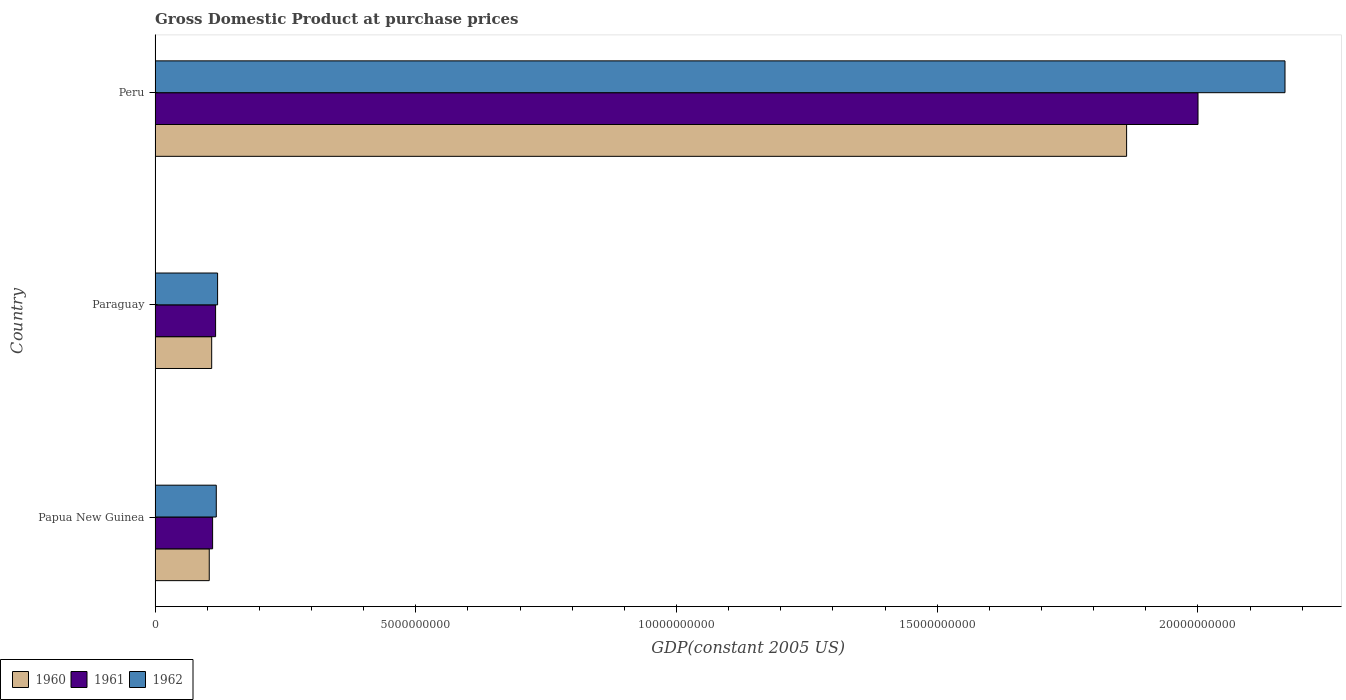How many different coloured bars are there?
Keep it short and to the point. 3. Are the number of bars per tick equal to the number of legend labels?
Offer a very short reply. Yes. What is the label of the 2nd group of bars from the top?
Your answer should be very brief. Paraguay. In how many cases, is the number of bars for a given country not equal to the number of legend labels?
Provide a short and direct response. 0. What is the GDP at purchase prices in 1961 in Paraguay?
Ensure brevity in your answer.  1.16e+09. Across all countries, what is the maximum GDP at purchase prices in 1961?
Your answer should be very brief. 2.00e+1. Across all countries, what is the minimum GDP at purchase prices in 1960?
Your response must be concise. 1.04e+09. In which country was the GDP at purchase prices in 1961 minimum?
Offer a terse response. Papua New Guinea. What is the total GDP at purchase prices in 1961 in the graph?
Keep it short and to the point. 2.23e+1. What is the difference between the GDP at purchase prices in 1961 in Papua New Guinea and that in Peru?
Offer a terse response. -1.89e+1. What is the difference between the GDP at purchase prices in 1962 in Peru and the GDP at purchase prices in 1960 in Papua New Guinea?
Provide a succinct answer. 2.06e+1. What is the average GDP at purchase prices in 1961 per country?
Provide a succinct answer. 7.42e+09. What is the difference between the GDP at purchase prices in 1961 and GDP at purchase prices in 1962 in Paraguay?
Your answer should be compact. -3.83e+07. What is the ratio of the GDP at purchase prices in 1961 in Papua New Guinea to that in Peru?
Keep it short and to the point. 0.06. What is the difference between the highest and the second highest GDP at purchase prices in 1961?
Make the answer very short. 1.88e+1. What is the difference between the highest and the lowest GDP at purchase prices in 1961?
Offer a terse response. 1.89e+1. Is the sum of the GDP at purchase prices in 1960 in Papua New Guinea and Peru greater than the maximum GDP at purchase prices in 1961 across all countries?
Provide a succinct answer. No. What does the 3rd bar from the bottom in Papua New Guinea represents?
Make the answer very short. 1962. How many countries are there in the graph?
Your answer should be very brief. 3. What is the difference between two consecutive major ticks on the X-axis?
Keep it short and to the point. 5.00e+09. Does the graph contain grids?
Provide a succinct answer. No. How many legend labels are there?
Your response must be concise. 3. How are the legend labels stacked?
Provide a short and direct response. Horizontal. What is the title of the graph?
Offer a terse response. Gross Domestic Product at purchase prices. What is the label or title of the X-axis?
Make the answer very short. GDP(constant 2005 US). What is the label or title of the Y-axis?
Offer a terse response. Country. What is the GDP(constant 2005 US) in 1960 in Papua New Guinea?
Offer a terse response. 1.04e+09. What is the GDP(constant 2005 US) of 1961 in Papua New Guinea?
Offer a terse response. 1.10e+09. What is the GDP(constant 2005 US) in 1962 in Papua New Guinea?
Offer a very short reply. 1.17e+09. What is the GDP(constant 2005 US) in 1960 in Paraguay?
Your answer should be compact. 1.09e+09. What is the GDP(constant 2005 US) in 1961 in Paraguay?
Provide a succinct answer. 1.16e+09. What is the GDP(constant 2005 US) in 1962 in Paraguay?
Ensure brevity in your answer.  1.20e+09. What is the GDP(constant 2005 US) of 1960 in Peru?
Offer a terse response. 1.86e+1. What is the GDP(constant 2005 US) in 1961 in Peru?
Your answer should be very brief. 2.00e+1. What is the GDP(constant 2005 US) of 1962 in Peru?
Provide a succinct answer. 2.17e+1. Across all countries, what is the maximum GDP(constant 2005 US) of 1960?
Provide a short and direct response. 1.86e+1. Across all countries, what is the maximum GDP(constant 2005 US) of 1961?
Ensure brevity in your answer.  2.00e+1. Across all countries, what is the maximum GDP(constant 2005 US) in 1962?
Provide a short and direct response. 2.17e+1. Across all countries, what is the minimum GDP(constant 2005 US) in 1960?
Provide a short and direct response. 1.04e+09. Across all countries, what is the minimum GDP(constant 2005 US) in 1961?
Make the answer very short. 1.10e+09. Across all countries, what is the minimum GDP(constant 2005 US) in 1962?
Your response must be concise. 1.17e+09. What is the total GDP(constant 2005 US) of 1960 in the graph?
Make the answer very short. 2.08e+1. What is the total GDP(constant 2005 US) in 1961 in the graph?
Ensure brevity in your answer.  2.23e+1. What is the total GDP(constant 2005 US) in 1962 in the graph?
Offer a terse response. 2.40e+1. What is the difference between the GDP(constant 2005 US) of 1960 in Papua New Guinea and that in Paraguay?
Provide a succinct answer. -4.67e+07. What is the difference between the GDP(constant 2005 US) in 1961 in Papua New Guinea and that in Paraguay?
Your answer should be compact. -5.74e+07. What is the difference between the GDP(constant 2005 US) in 1962 in Papua New Guinea and that in Paraguay?
Offer a terse response. -2.54e+07. What is the difference between the GDP(constant 2005 US) of 1960 in Papua New Guinea and that in Peru?
Offer a terse response. -1.76e+1. What is the difference between the GDP(constant 2005 US) of 1961 in Papua New Guinea and that in Peru?
Offer a terse response. -1.89e+1. What is the difference between the GDP(constant 2005 US) of 1962 in Papua New Guinea and that in Peru?
Offer a very short reply. -2.05e+1. What is the difference between the GDP(constant 2005 US) in 1960 in Paraguay and that in Peru?
Ensure brevity in your answer.  -1.75e+1. What is the difference between the GDP(constant 2005 US) in 1961 in Paraguay and that in Peru?
Offer a very short reply. -1.88e+1. What is the difference between the GDP(constant 2005 US) of 1962 in Paraguay and that in Peru?
Give a very brief answer. -2.05e+1. What is the difference between the GDP(constant 2005 US) of 1960 in Papua New Guinea and the GDP(constant 2005 US) of 1961 in Paraguay?
Offer a very short reply. -1.22e+08. What is the difference between the GDP(constant 2005 US) of 1960 in Papua New Guinea and the GDP(constant 2005 US) of 1962 in Paraguay?
Offer a very short reply. -1.60e+08. What is the difference between the GDP(constant 2005 US) of 1961 in Papua New Guinea and the GDP(constant 2005 US) of 1962 in Paraguay?
Ensure brevity in your answer.  -9.58e+07. What is the difference between the GDP(constant 2005 US) in 1960 in Papua New Guinea and the GDP(constant 2005 US) in 1961 in Peru?
Provide a short and direct response. -1.90e+1. What is the difference between the GDP(constant 2005 US) in 1960 in Papua New Guinea and the GDP(constant 2005 US) in 1962 in Peru?
Offer a very short reply. -2.06e+1. What is the difference between the GDP(constant 2005 US) in 1961 in Papua New Guinea and the GDP(constant 2005 US) in 1962 in Peru?
Offer a terse response. -2.06e+1. What is the difference between the GDP(constant 2005 US) in 1960 in Paraguay and the GDP(constant 2005 US) in 1961 in Peru?
Your response must be concise. -1.89e+1. What is the difference between the GDP(constant 2005 US) of 1960 in Paraguay and the GDP(constant 2005 US) of 1962 in Peru?
Make the answer very short. -2.06e+1. What is the difference between the GDP(constant 2005 US) in 1961 in Paraguay and the GDP(constant 2005 US) in 1962 in Peru?
Give a very brief answer. -2.05e+1. What is the average GDP(constant 2005 US) of 1960 per country?
Provide a succinct answer. 6.92e+09. What is the average GDP(constant 2005 US) of 1961 per country?
Your answer should be very brief. 7.42e+09. What is the average GDP(constant 2005 US) in 1962 per country?
Provide a short and direct response. 8.01e+09. What is the difference between the GDP(constant 2005 US) of 1960 and GDP(constant 2005 US) of 1961 in Papua New Guinea?
Provide a succinct answer. -6.42e+07. What is the difference between the GDP(constant 2005 US) of 1960 and GDP(constant 2005 US) of 1962 in Papua New Guinea?
Ensure brevity in your answer.  -1.35e+08. What is the difference between the GDP(constant 2005 US) in 1961 and GDP(constant 2005 US) in 1962 in Papua New Guinea?
Offer a very short reply. -7.03e+07. What is the difference between the GDP(constant 2005 US) in 1960 and GDP(constant 2005 US) in 1961 in Paraguay?
Your answer should be very brief. -7.49e+07. What is the difference between the GDP(constant 2005 US) of 1960 and GDP(constant 2005 US) of 1962 in Paraguay?
Provide a succinct answer. -1.13e+08. What is the difference between the GDP(constant 2005 US) in 1961 and GDP(constant 2005 US) in 1962 in Paraguay?
Offer a terse response. -3.83e+07. What is the difference between the GDP(constant 2005 US) in 1960 and GDP(constant 2005 US) in 1961 in Peru?
Give a very brief answer. -1.37e+09. What is the difference between the GDP(constant 2005 US) of 1960 and GDP(constant 2005 US) of 1962 in Peru?
Ensure brevity in your answer.  -3.04e+09. What is the difference between the GDP(constant 2005 US) of 1961 and GDP(constant 2005 US) of 1962 in Peru?
Ensure brevity in your answer.  -1.67e+09. What is the ratio of the GDP(constant 2005 US) of 1961 in Papua New Guinea to that in Paraguay?
Keep it short and to the point. 0.95. What is the ratio of the GDP(constant 2005 US) of 1962 in Papua New Guinea to that in Paraguay?
Offer a terse response. 0.98. What is the ratio of the GDP(constant 2005 US) in 1960 in Papua New Guinea to that in Peru?
Provide a succinct answer. 0.06. What is the ratio of the GDP(constant 2005 US) in 1961 in Papua New Guinea to that in Peru?
Your response must be concise. 0.06. What is the ratio of the GDP(constant 2005 US) of 1962 in Papua New Guinea to that in Peru?
Your answer should be compact. 0.05. What is the ratio of the GDP(constant 2005 US) of 1960 in Paraguay to that in Peru?
Ensure brevity in your answer.  0.06. What is the ratio of the GDP(constant 2005 US) in 1961 in Paraguay to that in Peru?
Provide a succinct answer. 0.06. What is the ratio of the GDP(constant 2005 US) of 1962 in Paraguay to that in Peru?
Your response must be concise. 0.06. What is the difference between the highest and the second highest GDP(constant 2005 US) in 1960?
Provide a succinct answer. 1.75e+1. What is the difference between the highest and the second highest GDP(constant 2005 US) of 1961?
Offer a terse response. 1.88e+1. What is the difference between the highest and the second highest GDP(constant 2005 US) in 1962?
Your response must be concise. 2.05e+1. What is the difference between the highest and the lowest GDP(constant 2005 US) of 1960?
Provide a succinct answer. 1.76e+1. What is the difference between the highest and the lowest GDP(constant 2005 US) in 1961?
Your response must be concise. 1.89e+1. What is the difference between the highest and the lowest GDP(constant 2005 US) of 1962?
Give a very brief answer. 2.05e+1. 